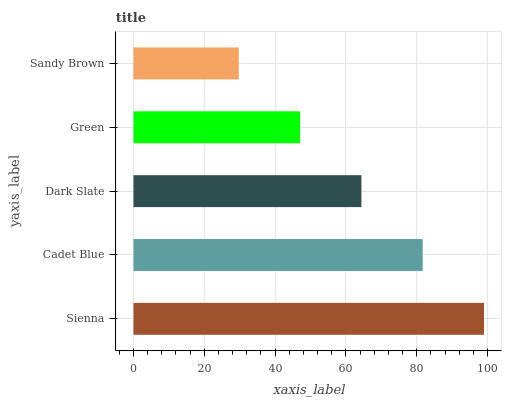Is Sandy Brown the minimum?
Answer yes or no. Yes. Is Sienna the maximum?
Answer yes or no. Yes. Is Cadet Blue the minimum?
Answer yes or no. No. Is Cadet Blue the maximum?
Answer yes or no. No. Is Sienna greater than Cadet Blue?
Answer yes or no. Yes. Is Cadet Blue less than Sienna?
Answer yes or no. Yes. Is Cadet Blue greater than Sienna?
Answer yes or no. No. Is Sienna less than Cadet Blue?
Answer yes or no. No. Is Dark Slate the high median?
Answer yes or no. Yes. Is Dark Slate the low median?
Answer yes or no. Yes. Is Cadet Blue the high median?
Answer yes or no. No. Is Cadet Blue the low median?
Answer yes or no. No. 